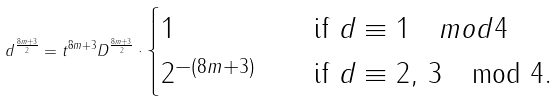<formula> <loc_0><loc_0><loc_500><loc_500>d ^ { \frac { 8 m + 3 } { 2 } } = t ^ { 8 m + 3 } D ^ { \frac { 8 m + 3 } { 2 } } \cdot \begin{cases} 1 \quad & \text {if } d \equiv 1 \quad m o d 4 \\ 2 ^ { - ( 8 m + 3 ) } \quad & \text {if } d \equiv 2 , \, 3 \mod 4 . \end{cases}</formula> 